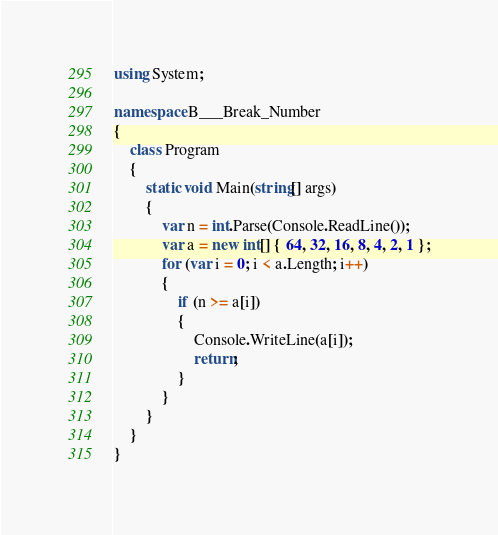Convert code to text. <code><loc_0><loc_0><loc_500><loc_500><_C#_>using System;

namespace B___Break_Number
{
    class Program
    {
        static void Main(string[] args)
        {
            var n = int.Parse(Console.ReadLine());
            var a = new int[] { 64, 32, 16, 8, 4, 2, 1 };
            for (var i = 0; i < a.Length; i++)
            {
                if (n >= a[i])
                {
                    Console.WriteLine(a[i]);
                    return;
                }
            }
        }
    }
}</code> 